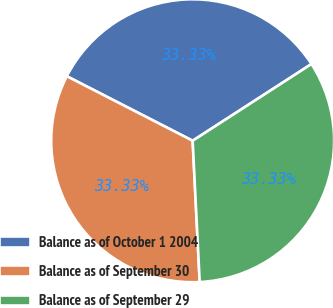Convert chart. <chart><loc_0><loc_0><loc_500><loc_500><pie_chart><fcel>Balance as of October 1 2004<fcel>Balance as of September 30<fcel>Balance as of September 29<nl><fcel>33.33%<fcel>33.33%<fcel>33.33%<nl></chart> 